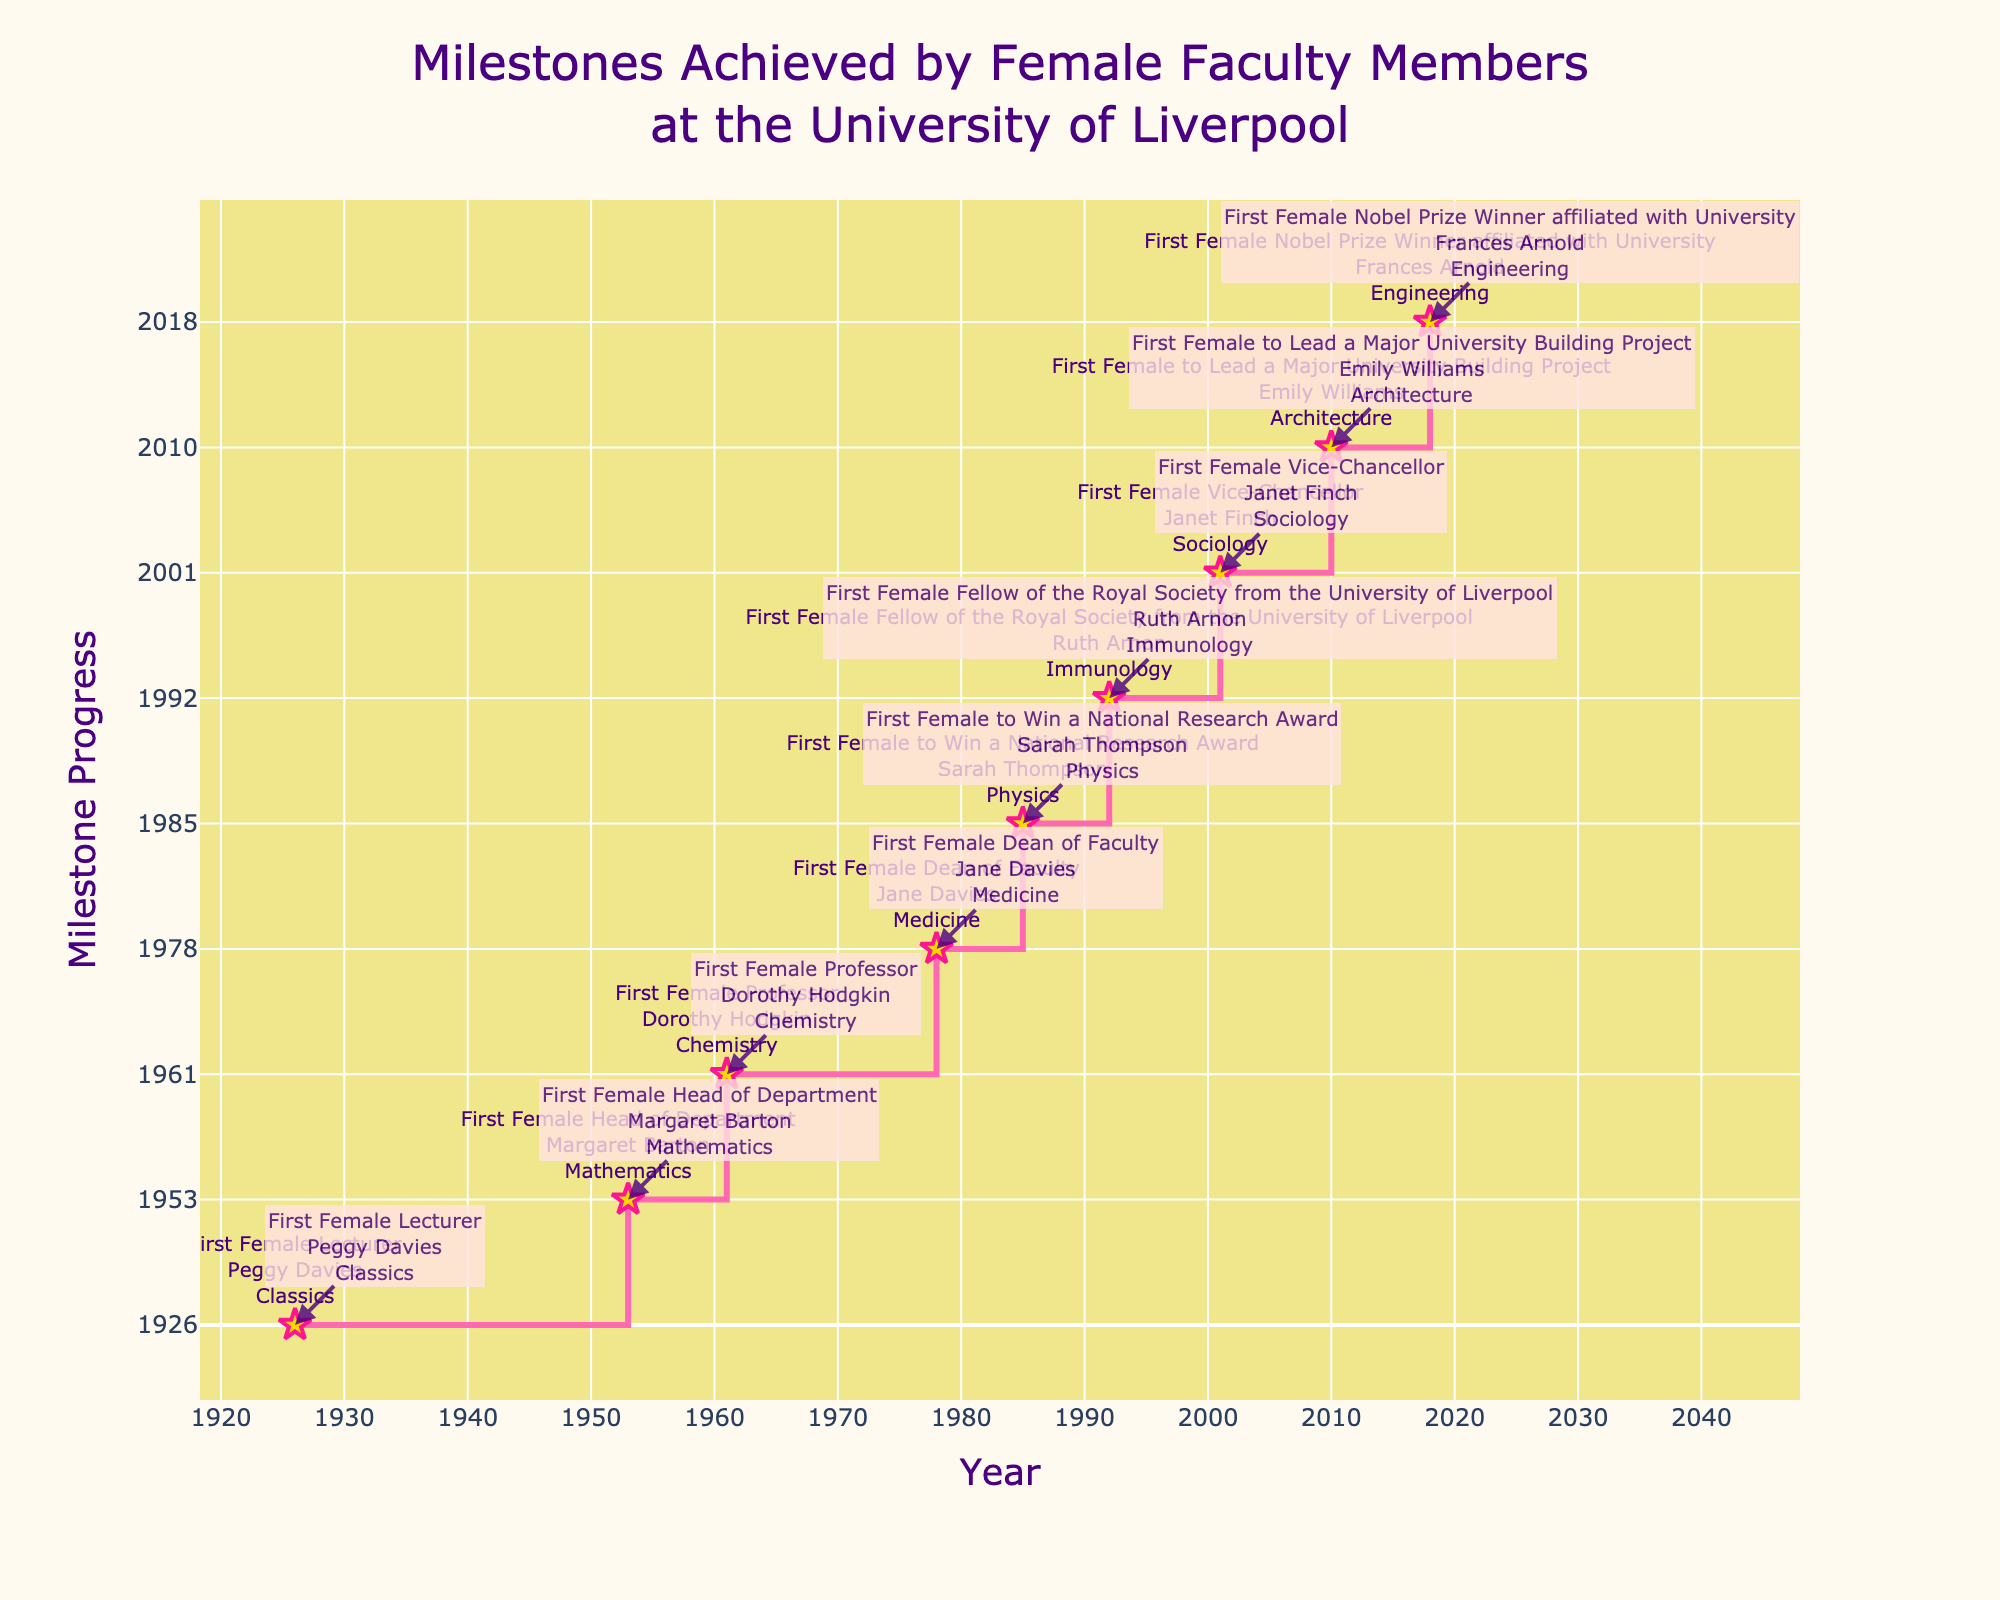what is the title of the figure? The title is mentioned at the top of the figure in the center. It reads, "Milestones Achieved by Female Faculty Members at the University of Liverpool".
Answer: Milestones Achieved by Female Faculty Members at the University of Liverpool What is the color of the background of the plot? The background color of the plot area is light yellow. This can be seen surrounding the stair plot.
Answer: Light yellow Who was the first female Professor at the University of Liverpool? According to the milestone annotations in the figure, Dorothy Hodgkin was the first female Professor in the year 1961 in the Chemistry department.
Answer: Dorothy Hodgkin How many milestones are marked in the figure? By counting the number of data points (stars) marked along the stair plot, we can see there are 9 milestones plotted.
Answer: 9 What year did the first Female Vice-Chancellor get appointed? By locating the "First Female Vice-Chancellor" milestone on the x-axis, it falls on the year 2001.
Answer: 2001 Which department had the first female to win a National Research Award? From the annotations in the plot, the "First Female to Win a National Research Award" is in Physics.
Answer: Physics Compare the years between the first female Head of Department and the first female Dean of Faculty? The first female Head of Department achieved the milestone in 1953, and the first female Dean of Faculty in 1978. The difference between these years is 1978 - 1953 = 25 years.
Answer: 25 years Which milestone came first: first female Lecturer or first female Professor? By observing the plot and following the progression of milestones, the first female Lecturer (1926) occurred before the first female Professor (1961).
Answer: First female Lecturer Who was the first Female Nobel Prize Winner affiliated with the university, and in which year? The plot annotation for "First Female Nobel Prize Winner affiliated with University" shows Frances Arnold in the year 2018.
Answer: Frances Arnold, 2018 What is the time gap between the first female Lecturer and the first Female Nobel Prize Winner affiliated with the University? The first female Lecturer was in 1926 and the first Female Nobel Prize Winner was in 2018. The time gap between these milestones is 2018 - 1926 = 92 years.
Answer: 92 years 